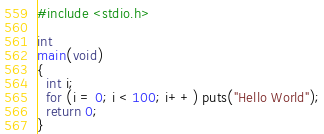<code> <loc_0><loc_0><loc_500><loc_500><_C_>#include <stdio.h>

int
main(void)
{
  int i;
  for (i = 0; i < 100; i++) puts("Hello World");
  return 0;
}</code> 